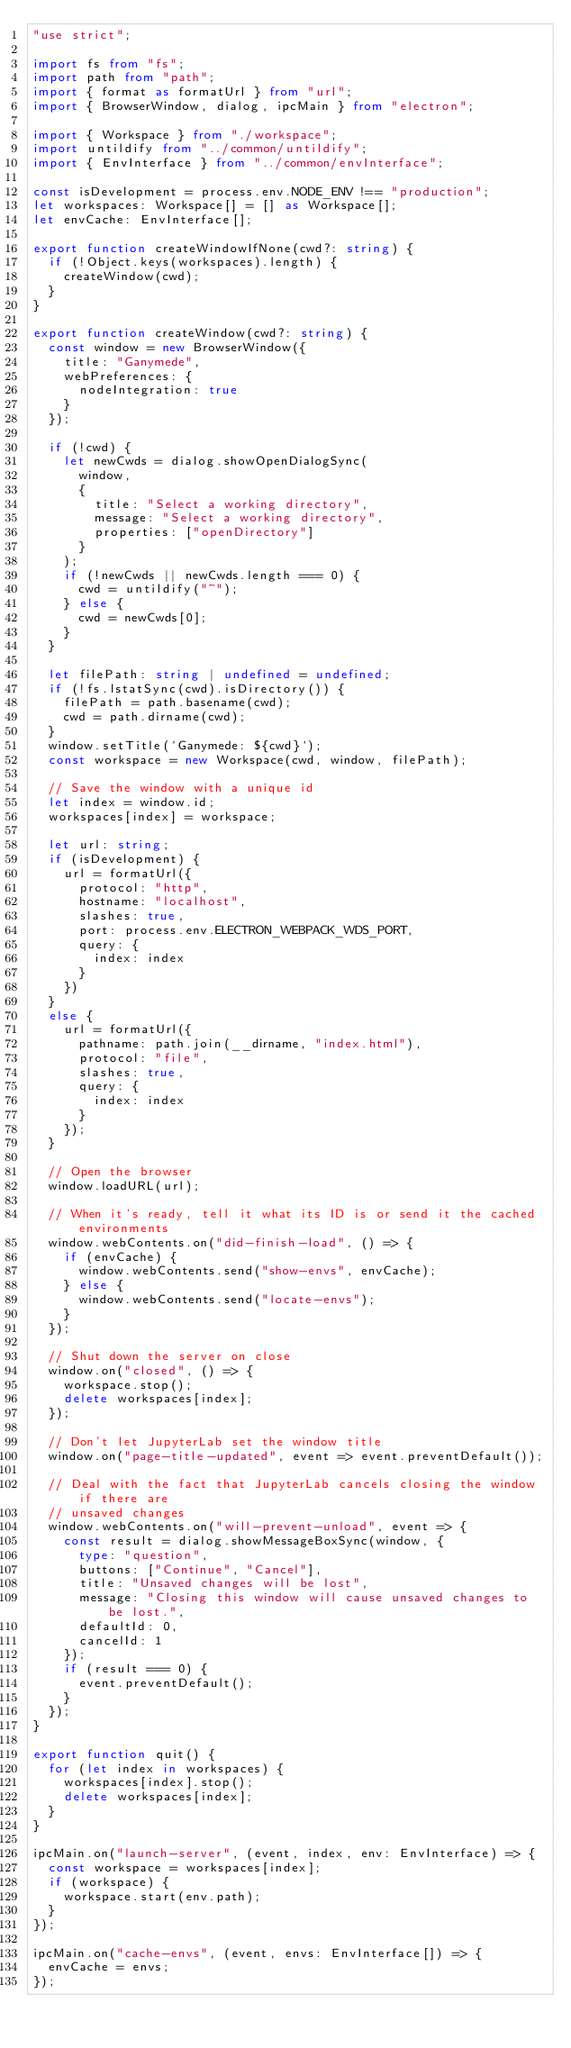<code> <loc_0><loc_0><loc_500><loc_500><_TypeScript_>"use strict";

import fs from "fs";
import path from "path";
import { format as formatUrl } from "url";
import { BrowserWindow, dialog, ipcMain } from "electron";

import { Workspace } from "./workspace";
import untildify from "../common/untildify";
import { EnvInterface } from "../common/envInterface";

const isDevelopment = process.env.NODE_ENV !== "production";
let workspaces: Workspace[] = [] as Workspace[];
let envCache: EnvInterface[];

export function createWindowIfNone(cwd?: string) {
  if (!Object.keys(workspaces).length) {
    createWindow(cwd);
  }
}

export function createWindow(cwd?: string) {
  const window = new BrowserWindow({
    title: "Ganymede",
    webPreferences: {
      nodeIntegration: true
    }
  });

  if (!cwd) {
    let newCwds = dialog.showOpenDialogSync(
      window,
      {
        title: "Select a working directory",
        message: "Select a working directory",
        properties: ["openDirectory"]
      }
    );
    if (!newCwds || newCwds.length === 0) {
      cwd = untildify("~");
    } else {
      cwd = newCwds[0];
    }
  }

  let filePath: string | undefined = undefined;
  if (!fs.lstatSync(cwd).isDirectory()) {
    filePath = path.basename(cwd);
    cwd = path.dirname(cwd);
  }
  window.setTitle(`Ganymede: ${cwd}`);
  const workspace = new Workspace(cwd, window, filePath);

  // Save the window with a unique id
  let index = window.id;
  workspaces[index] = workspace;

  let url: string;
  if (isDevelopment) {
    url = formatUrl({
      protocol: "http",
      hostname: "localhost",
      slashes: true,
      port: process.env.ELECTRON_WEBPACK_WDS_PORT,
      query: {
        index: index
      }
    })
  }
  else {
    url = formatUrl({
      pathname: path.join(__dirname, "index.html"),
      protocol: "file",
      slashes: true,
      query: {
        index: index
      }
    });
  }

  // Open the browser
  window.loadURL(url);

  // When it's ready, tell it what its ID is or send it the cached environments
  window.webContents.on("did-finish-load", () => {
    if (envCache) {
      window.webContents.send("show-envs", envCache);
    } else {
      window.webContents.send("locate-envs");
    }
  });

  // Shut down the server on close
  window.on("closed", () => {
    workspace.stop();
    delete workspaces[index];
  });

  // Don't let JupyterLab set the window title
  window.on("page-title-updated", event => event.preventDefault());

  // Deal with the fact that JupyterLab cancels closing the window if there are
  // unsaved changes
  window.webContents.on("will-prevent-unload", event => {
    const result = dialog.showMessageBoxSync(window, {
      type: "question",
      buttons: ["Continue", "Cancel"],
      title: "Unsaved changes will be lost",
      message: "Closing this window will cause unsaved changes to be lost.",
      defaultId: 0,
      cancelId: 1
    });
    if (result === 0) {
      event.preventDefault();
    }
  });
}

export function quit() {
  for (let index in workspaces) {
    workspaces[index].stop();
    delete workspaces[index];
  }
}

ipcMain.on("launch-server", (event, index, env: EnvInterface) => {
  const workspace = workspaces[index];
  if (workspace) {
    workspace.start(env.path);
  }
});

ipcMain.on("cache-envs", (event, envs: EnvInterface[]) => {
  envCache = envs;
});
</code> 